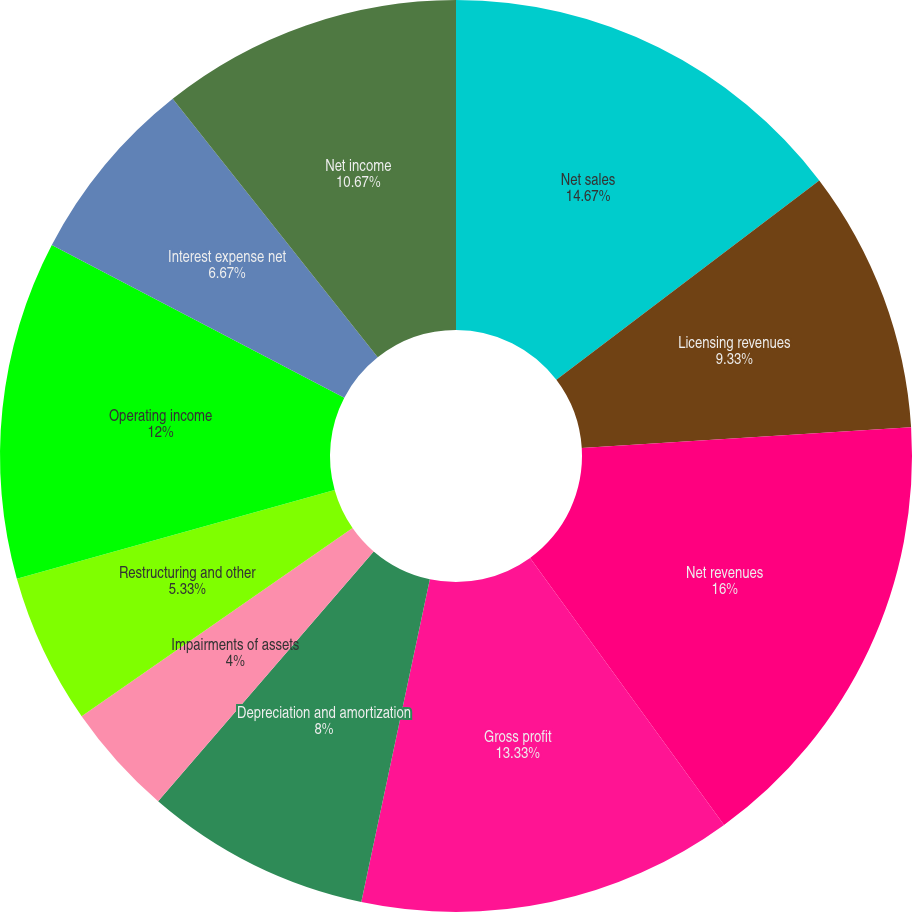Convert chart to OTSL. <chart><loc_0><loc_0><loc_500><loc_500><pie_chart><fcel>Net sales<fcel>Licensing revenues<fcel>Net revenues<fcel>Gross profit<fcel>Depreciation and amortization<fcel>Impairments of assets<fcel>Restructuring and other<fcel>Operating income<fcel>Interest expense net<fcel>Net income<nl><fcel>14.67%<fcel>9.33%<fcel>16.0%<fcel>13.33%<fcel>8.0%<fcel>4.0%<fcel>5.33%<fcel>12.0%<fcel>6.67%<fcel>10.67%<nl></chart> 